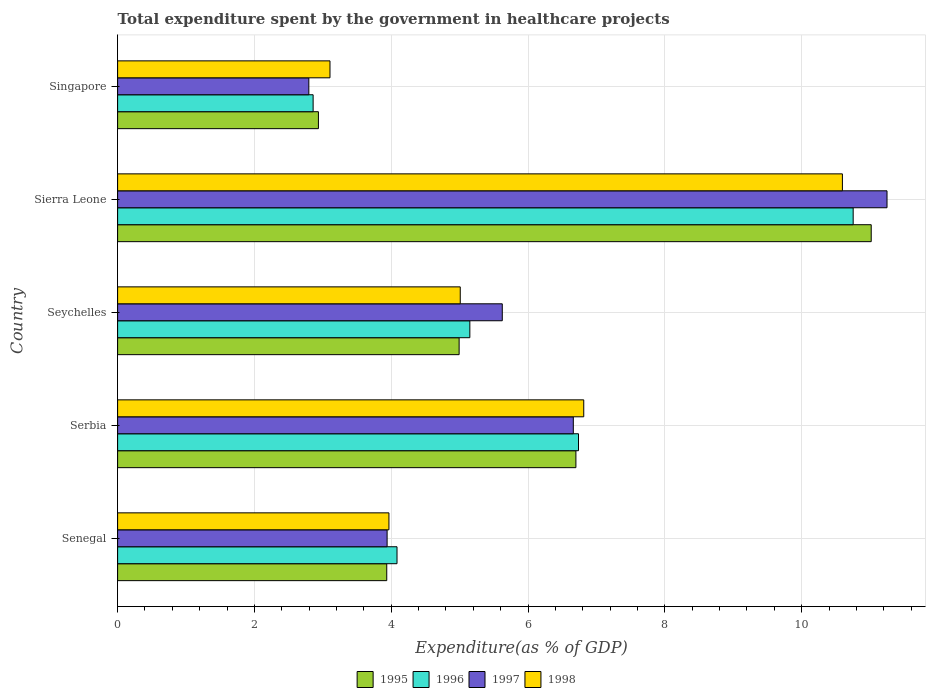How many different coloured bars are there?
Provide a short and direct response. 4. Are the number of bars per tick equal to the number of legend labels?
Your answer should be compact. Yes. How many bars are there on the 5th tick from the top?
Keep it short and to the point. 4. What is the label of the 5th group of bars from the top?
Your answer should be very brief. Senegal. In how many cases, is the number of bars for a given country not equal to the number of legend labels?
Provide a short and direct response. 0. What is the total expenditure spent by the government in healthcare projects in 1997 in Senegal?
Your response must be concise. 3.94. Across all countries, what is the maximum total expenditure spent by the government in healthcare projects in 1996?
Offer a terse response. 10.75. Across all countries, what is the minimum total expenditure spent by the government in healthcare projects in 1997?
Your answer should be very brief. 2.8. In which country was the total expenditure spent by the government in healthcare projects in 1997 maximum?
Provide a succinct answer. Sierra Leone. In which country was the total expenditure spent by the government in healthcare projects in 1997 minimum?
Provide a short and direct response. Singapore. What is the total total expenditure spent by the government in healthcare projects in 1995 in the graph?
Your response must be concise. 29.58. What is the difference between the total expenditure spent by the government in healthcare projects in 1997 in Senegal and that in Sierra Leone?
Offer a terse response. -7.31. What is the difference between the total expenditure spent by the government in healthcare projects in 1998 in Serbia and the total expenditure spent by the government in healthcare projects in 1997 in Sierra Leone?
Your answer should be compact. -4.43. What is the average total expenditure spent by the government in healthcare projects in 1995 per country?
Make the answer very short. 5.92. What is the difference between the total expenditure spent by the government in healthcare projects in 1995 and total expenditure spent by the government in healthcare projects in 1998 in Senegal?
Make the answer very short. -0.03. In how many countries, is the total expenditure spent by the government in healthcare projects in 1995 greater than 8.4 %?
Offer a very short reply. 1. What is the ratio of the total expenditure spent by the government in healthcare projects in 1995 in Senegal to that in Sierra Leone?
Offer a terse response. 0.36. Is the total expenditure spent by the government in healthcare projects in 1995 in Senegal less than that in Serbia?
Make the answer very short. Yes. Is the difference between the total expenditure spent by the government in healthcare projects in 1995 in Sierra Leone and Singapore greater than the difference between the total expenditure spent by the government in healthcare projects in 1998 in Sierra Leone and Singapore?
Give a very brief answer. Yes. What is the difference between the highest and the second highest total expenditure spent by the government in healthcare projects in 1996?
Keep it short and to the point. 4.02. What is the difference between the highest and the lowest total expenditure spent by the government in healthcare projects in 1998?
Make the answer very short. 7.49. In how many countries, is the total expenditure spent by the government in healthcare projects in 1997 greater than the average total expenditure spent by the government in healthcare projects in 1997 taken over all countries?
Provide a succinct answer. 2. Is it the case that in every country, the sum of the total expenditure spent by the government in healthcare projects in 1998 and total expenditure spent by the government in healthcare projects in 1995 is greater than the sum of total expenditure spent by the government in healthcare projects in 1996 and total expenditure spent by the government in healthcare projects in 1997?
Make the answer very short. No. What is the difference between two consecutive major ticks on the X-axis?
Provide a short and direct response. 2. Does the graph contain grids?
Ensure brevity in your answer.  Yes. Where does the legend appear in the graph?
Provide a short and direct response. Bottom center. What is the title of the graph?
Provide a succinct answer. Total expenditure spent by the government in healthcare projects. What is the label or title of the X-axis?
Your answer should be compact. Expenditure(as % of GDP). What is the Expenditure(as % of GDP) of 1995 in Senegal?
Give a very brief answer. 3.93. What is the Expenditure(as % of GDP) in 1996 in Senegal?
Keep it short and to the point. 4.08. What is the Expenditure(as % of GDP) of 1997 in Senegal?
Offer a very short reply. 3.94. What is the Expenditure(as % of GDP) in 1998 in Senegal?
Ensure brevity in your answer.  3.97. What is the Expenditure(as % of GDP) of 1995 in Serbia?
Make the answer very short. 6.7. What is the Expenditure(as % of GDP) in 1996 in Serbia?
Your answer should be compact. 6.74. What is the Expenditure(as % of GDP) of 1997 in Serbia?
Provide a succinct answer. 6.66. What is the Expenditure(as % of GDP) in 1998 in Serbia?
Your answer should be compact. 6.81. What is the Expenditure(as % of GDP) of 1995 in Seychelles?
Keep it short and to the point. 4.99. What is the Expenditure(as % of GDP) in 1996 in Seychelles?
Provide a succinct answer. 5.15. What is the Expenditure(as % of GDP) of 1997 in Seychelles?
Keep it short and to the point. 5.62. What is the Expenditure(as % of GDP) in 1998 in Seychelles?
Keep it short and to the point. 5.01. What is the Expenditure(as % of GDP) in 1995 in Sierra Leone?
Keep it short and to the point. 11.02. What is the Expenditure(as % of GDP) of 1996 in Sierra Leone?
Offer a terse response. 10.75. What is the Expenditure(as % of GDP) in 1997 in Sierra Leone?
Your answer should be very brief. 11.25. What is the Expenditure(as % of GDP) of 1998 in Sierra Leone?
Make the answer very short. 10.59. What is the Expenditure(as % of GDP) in 1995 in Singapore?
Make the answer very short. 2.94. What is the Expenditure(as % of GDP) in 1996 in Singapore?
Your answer should be compact. 2.86. What is the Expenditure(as % of GDP) in 1997 in Singapore?
Your answer should be very brief. 2.8. What is the Expenditure(as % of GDP) of 1998 in Singapore?
Ensure brevity in your answer.  3.1. Across all countries, what is the maximum Expenditure(as % of GDP) of 1995?
Provide a short and direct response. 11.02. Across all countries, what is the maximum Expenditure(as % of GDP) of 1996?
Your answer should be very brief. 10.75. Across all countries, what is the maximum Expenditure(as % of GDP) in 1997?
Ensure brevity in your answer.  11.25. Across all countries, what is the maximum Expenditure(as % of GDP) of 1998?
Your answer should be very brief. 10.59. Across all countries, what is the minimum Expenditure(as % of GDP) in 1995?
Your answer should be very brief. 2.94. Across all countries, what is the minimum Expenditure(as % of GDP) of 1996?
Offer a terse response. 2.86. Across all countries, what is the minimum Expenditure(as % of GDP) in 1997?
Ensure brevity in your answer.  2.8. Across all countries, what is the minimum Expenditure(as % of GDP) of 1998?
Your answer should be compact. 3.1. What is the total Expenditure(as % of GDP) in 1995 in the graph?
Keep it short and to the point. 29.58. What is the total Expenditure(as % of GDP) in 1996 in the graph?
Your answer should be very brief. 29.58. What is the total Expenditure(as % of GDP) in 1997 in the graph?
Your answer should be very brief. 30.27. What is the total Expenditure(as % of GDP) in 1998 in the graph?
Your answer should be very brief. 29.49. What is the difference between the Expenditure(as % of GDP) of 1995 in Senegal and that in Serbia?
Give a very brief answer. -2.76. What is the difference between the Expenditure(as % of GDP) in 1996 in Senegal and that in Serbia?
Offer a very short reply. -2.65. What is the difference between the Expenditure(as % of GDP) in 1997 in Senegal and that in Serbia?
Offer a very short reply. -2.72. What is the difference between the Expenditure(as % of GDP) in 1998 in Senegal and that in Serbia?
Make the answer very short. -2.85. What is the difference between the Expenditure(as % of GDP) in 1995 in Senegal and that in Seychelles?
Provide a short and direct response. -1.06. What is the difference between the Expenditure(as % of GDP) in 1996 in Senegal and that in Seychelles?
Your answer should be compact. -1.06. What is the difference between the Expenditure(as % of GDP) in 1997 in Senegal and that in Seychelles?
Make the answer very short. -1.68. What is the difference between the Expenditure(as % of GDP) in 1998 in Senegal and that in Seychelles?
Give a very brief answer. -1.04. What is the difference between the Expenditure(as % of GDP) in 1995 in Senegal and that in Sierra Leone?
Give a very brief answer. -7.08. What is the difference between the Expenditure(as % of GDP) of 1996 in Senegal and that in Sierra Leone?
Provide a succinct answer. -6.67. What is the difference between the Expenditure(as % of GDP) in 1997 in Senegal and that in Sierra Leone?
Your answer should be very brief. -7.31. What is the difference between the Expenditure(as % of GDP) in 1998 in Senegal and that in Sierra Leone?
Provide a short and direct response. -6.63. What is the difference between the Expenditure(as % of GDP) in 1996 in Senegal and that in Singapore?
Offer a terse response. 1.23. What is the difference between the Expenditure(as % of GDP) of 1997 in Senegal and that in Singapore?
Your response must be concise. 1.14. What is the difference between the Expenditure(as % of GDP) in 1998 in Senegal and that in Singapore?
Ensure brevity in your answer.  0.86. What is the difference between the Expenditure(as % of GDP) of 1995 in Serbia and that in Seychelles?
Offer a terse response. 1.71. What is the difference between the Expenditure(as % of GDP) in 1996 in Serbia and that in Seychelles?
Your response must be concise. 1.59. What is the difference between the Expenditure(as % of GDP) of 1997 in Serbia and that in Seychelles?
Ensure brevity in your answer.  1.04. What is the difference between the Expenditure(as % of GDP) in 1998 in Serbia and that in Seychelles?
Make the answer very short. 1.81. What is the difference between the Expenditure(as % of GDP) of 1995 in Serbia and that in Sierra Leone?
Provide a short and direct response. -4.32. What is the difference between the Expenditure(as % of GDP) of 1996 in Serbia and that in Sierra Leone?
Provide a succinct answer. -4.02. What is the difference between the Expenditure(as % of GDP) of 1997 in Serbia and that in Sierra Leone?
Your answer should be very brief. -4.59. What is the difference between the Expenditure(as % of GDP) in 1998 in Serbia and that in Sierra Leone?
Offer a terse response. -3.78. What is the difference between the Expenditure(as % of GDP) of 1995 in Serbia and that in Singapore?
Provide a short and direct response. 3.76. What is the difference between the Expenditure(as % of GDP) of 1996 in Serbia and that in Singapore?
Ensure brevity in your answer.  3.88. What is the difference between the Expenditure(as % of GDP) of 1997 in Serbia and that in Singapore?
Make the answer very short. 3.87. What is the difference between the Expenditure(as % of GDP) in 1998 in Serbia and that in Singapore?
Ensure brevity in your answer.  3.71. What is the difference between the Expenditure(as % of GDP) in 1995 in Seychelles and that in Sierra Leone?
Give a very brief answer. -6.02. What is the difference between the Expenditure(as % of GDP) in 1996 in Seychelles and that in Sierra Leone?
Keep it short and to the point. -5.6. What is the difference between the Expenditure(as % of GDP) in 1997 in Seychelles and that in Sierra Leone?
Ensure brevity in your answer.  -5.62. What is the difference between the Expenditure(as % of GDP) of 1998 in Seychelles and that in Sierra Leone?
Offer a terse response. -5.59. What is the difference between the Expenditure(as % of GDP) of 1995 in Seychelles and that in Singapore?
Your answer should be compact. 2.06. What is the difference between the Expenditure(as % of GDP) in 1996 in Seychelles and that in Singapore?
Ensure brevity in your answer.  2.29. What is the difference between the Expenditure(as % of GDP) in 1997 in Seychelles and that in Singapore?
Provide a short and direct response. 2.83. What is the difference between the Expenditure(as % of GDP) of 1998 in Seychelles and that in Singapore?
Provide a succinct answer. 1.9. What is the difference between the Expenditure(as % of GDP) in 1995 in Sierra Leone and that in Singapore?
Your answer should be very brief. 8.08. What is the difference between the Expenditure(as % of GDP) in 1996 in Sierra Leone and that in Singapore?
Your answer should be very brief. 7.89. What is the difference between the Expenditure(as % of GDP) in 1997 in Sierra Leone and that in Singapore?
Provide a short and direct response. 8.45. What is the difference between the Expenditure(as % of GDP) in 1998 in Sierra Leone and that in Singapore?
Keep it short and to the point. 7.49. What is the difference between the Expenditure(as % of GDP) of 1995 in Senegal and the Expenditure(as % of GDP) of 1996 in Serbia?
Provide a succinct answer. -2.8. What is the difference between the Expenditure(as % of GDP) of 1995 in Senegal and the Expenditure(as % of GDP) of 1997 in Serbia?
Keep it short and to the point. -2.73. What is the difference between the Expenditure(as % of GDP) of 1995 in Senegal and the Expenditure(as % of GDP) of 1998 in Serbia?
Offer a very short reply. -2.88. What is the difference between the Expenditure(as % of GDP) in 1996 in Senegal and the Expenditure(as % of GDP) in 1997 in Serbia?
Keep it short and to the point. -2.58. What is the difference between the Expenditure(as % of GDP) in 1996 in Senegal and the Expenditure(as % of GDP) in 1998 in Serbia?
Provide a succinct answer. -2.73. What is the difference between the Expenditure(as % of GDP) of 1997 in Senegal and the Expenditure(as % of GDP) of 1998 in Serbia?
Keep it short and to the point. -2.87. What is the difference between the Expenditure(as % of GDP) of 1995 in Senegal and the Expenditure(as % of GDP) of 1996 in Seychelles?
Make the answer very short. -1.21. What is the difference between the Expenditure(as % of GDP) in 1995 in Senegal and the Expenditure(as % of GDP) in 1997 in Seychelles?
Give a very brief answer. -1.69. What is the difference between the Expenditure(as % of GDP) of 1995 in Senegal and the Expenditure(as % of GDP) of 1998 in Seychelles?
Keep it short and to the point. -1.07. What is the difference between the Expenditure(as % of GDP) of 1996 in Senegal and the Expenditure(as % of GDP) of 1997 in Seychelles?
Offer a terse response. -1.54. What is the difference between the Expenditure(as % of GDP) in 1996 in Senegal and the Expenditure(as % of GDP) in 1998 in Seychelles?
Provide a succinct answer. -0.92. What is the difference between the Expenditure(as % of GDP) in 1997 in Senegal and the Expenditure(as % of GDP) in 1998 in Seychelles?
Keep it short and to the point. -1.07. What is the difference between the Expenditure(as % of GDP) in 1995 in Senegal and the Expenditure(as % of GDP) in 1996 in Sierra Leone?
Ensure brevity in your answer.  -6.82. What is the difference between the Expenditure(as % of GDP) in 1995 in Senegal and the Expenditure(as % of GDP) in 1997 in Sierra Leone?
Your answer should be compact. -7.31. What is the difference between the Expenditure(as % of GDP) in 1995 in Senegal and the Expenditure(as % of GDP) in 1998 in Sierra Leone?
Keep it short and to the point. -6.66. What is the difference between the Expenditure(as % of GDP) of 1996 in Senegal and the Expenditure(as % of GDP) of 1997 in Sierra Leone?
Ensure brevity in your answer.  -7.16. What is the difference between the Expenditure(as % of GDP) of 1996 in Senegal and the Expenditure(as % of GDP) of 1998 in Sierra Leone?
Give a very brief answer. -6.51. What is the difference between the Expenditure(as % of GDP) in 1997 in Senegal and the Expenditure(as % of GDP) in 1998 in Sierra Leone?
Your answer should be compact. -6.66. What is the difference between the Expenditure(as % of GDP) of 1995 in Senegal and the Expenditure(as % of GDP) of 1996 in Singapore?
Give a very brief answer. 1.08. What is the difference between the Expenditure(as % of GDP) of 1995 in Senegal and the Expenditure(as % of GDP) of 1997 in Singapore?
Offer a very short reply. 1.14. What is the difference between the Expenditure(as % of GDP) of 1995 in Senegal and the Expenditure(as % of GDP) of 1998 in Singapore?
Offer a terse response. 0.83. What is the difference between the Expenditure(as % of GDP) of 1996 in Senegal and the Expenditure(as % of GDP) of 1997 in Singapore?
Your response must be concise. 1.29. What is the difference between the Expenditure(as % of GDP) in 1996 in Senegal and the Expenditure(as % of GDP) in 1998 in Singapore?
Your answer should be very brief. 0.98. What is the difference between the Expenditure(as % of GDP) in 1997 in Senegal and the Expenditure(as % of GDP) in 1998 in Singapore?
Provide a short and direct response. 0.83. What is the difference between the Expenditure(as % of GDP) of 1995 in Serbia and the Expenditure(as % of GDP) of 1996 in Seychelles?
Your answer should be compact. 1.55. What is the difference between the Expenditure(as % of GDP) of 1995 in Serbia and the Expenditure(as % of GDP) of 1997 in Seychelles?
Keep it short and to the point. 1.08. What is the difference between the Expenditure(as % of GDP) of 1995 in Serbia and the Expenditure(as % of GDP) of 1998 in Seychelles?
Your answer should be very brief. 1.69. What is the difference between the Expenditure(as % of GDP) of 1996 in Serbia and the Expenditure(as % of GDP) of 1997 in Seychelles?
Provide a succinct answer. 1.11. What is the difference between the Expenditure(as % of GDP) in 1996 in Serbia and the Expenditure(as % of GDP) in 1998 in Seychelles?
Your answer should be compact. 1.73. What is the difference between the Expenditure(as % of GDP) of 1997 in Serbia and the Expenditure(as % of GDP) of 1998 in Seychelles?
Make the answer very short. 1.65. What is the difference between the Expenditure(as % of GDP) of 1995 in Serbia and the Expenditure(as % of GDP) of 1996 in Sierra Leone?
Provide a succinct answer. -4.05. What is the difference between the Expenditure(as % of GDP) in 1995 in Serbia and the Expenditure(as % of GDP) in 1997 in Sierra Leone?
Offer a terse response. -4.55. What is the difference between the Expenditure(as % of GDP) of 1995 in Serbia and the Expenditure(as % of GDP) of 1998 in Sierra Leone?
Give a very brief answer. -3.9. What is the difference between the Expenditure(as % of GDP) of 1996 in Serbia and the Expenditure(as % of GDP) of 1997 in Sierra Leone?
Your response must be concise. -4.51. What is the difference between the Expenditure(as % of GDP) in 1996 in Serbia and the Expenditure(as % of GDP) in 1998 in Sierra Leone?
Your answer should be very brief. -3.86. What is the difference between the Expenditure(as % of GDP) of 1997 in Serbia and the Expenditure(as % of GDP) of 1998 in Sierra Leone?
Your answer should be compact. -3.93. What is the difference between the Expenditure(as % of GDP) of 1995 in Serbia and the Expenditure(as % of GDP) of 1996 in Singapore?
Make the answer very short. 3.84. What is the difference between the Expenditure(as % of GDP) of 1995 in Serbia and the Expenditure(as % of GDP) of 1997 in Singapore?
Provide a succinct answer. 3.9. What is the difference between the Expenditure(as % of GDP) in 1995 in Serbia and the Expenditure(as % of GDP) in 1998 in Singapore?
Provide a succinct answer. 3.59. What is the difference between the Expenditure(as % of GDP) of 1996 in Serbia and the Expenditure(as % of GDP) of 1997 in Singapore?
Keep it short and to the point. 3.94. What is the difference between the Expenditure(as % of GDP) of 1996 in Serbia and the Expenditure(as % of GDP) of 1998 in Singapore?
Your answer should be compact. 3.63. What is the difference between the Expenditure(as % of GDP) in 1997 in Serbia and the Expenditure(as % of GDP) in 1998 in Singapore?
Ensure brevity in your answer.  3.56. What is the difference between the Expenditure(as % of GDP) in 1995 in Seychelles and the Expenditure(as % of GDP) in 1996 in Sierra Leone?
Keep it short and to the point. -5.76. What is the difference between the Expenditure(as % of GDP) of 1995 in Seychelles and the Expenditure(as % of GDP) of 1997 in Sierra Leone?
Provide a short and direct response. -6.25. What is the difference between the Expenditure(as % of GDP) of 1995 in Seychelles and the Expenditure(as % of GDP) of 1998 in Sierra Leone?
Ensure brevity in your answer.  -5.6. What is the difference between the Expenditure(as % of GDP) in 1996 in Seychelles and the Expenditure(as % of GDP) in 1997 in Sierra Leone?
Ensure brevity in your answer.  -6.1. What is the difference between the Expenditure(as % of GDP) of 1996 in Seychelles and the Expenditure(as % of GDP) of 1998 in Sierra Leone?
Make the answer very short. -5.45. What is the difference between the Expenditure(as % of GDP) in 1997 in Seychelles and the Expenditure(as % of GDP) in 1998 in Sierra Leone?
Your answer should be compact. -4.97. What is the difference between the Expenditure(as % of GDP) of 1995 in Seychelles and the Expenditure(as % of GDP) of 1996 in Singapore?
Your response must be concise. 2.13. What is the difference between the Expenditure(as % of GDP) of 1995 in Seychelles and the Expenditure(as % of GDP) of 1997 in Singapore?
Your answer should be very brief. 2.2. What is the difference between the Expenditure(as % of GDP) of 1995 in Seychelles and the Expenditure(as % of GDP) of 1998 in Singapore?
Offer a terse response. 1.89. What is the difference between the Expenditure(as % of GDP) of 1996 in Seychelles and the Expenditure(as % of GDP) of 1997 in Singapore?
Provide a short and direct response. 2.35. What is the difference between the Expenditure(as % of GDP) of 1996 in Seychelles and the Expenditure(as % of GDP) of 1998 in Singapore?
Offer a terse response. 2.04. What is the difference between the Expenditure(as % of GDP) of 1997 in Seychelles and the Expenditure(as % of GDP) of 1998 in Singapore?
Your answer should be very brief. 2.52. What is the difference between the Expenditure(as % of GDP) in 1995 in Sierra Leone and the Expenditure(as % of GDP) in 1996 in Singapore?
Keep it short and to the point. 8.16. What is the difference between the Expenditure(as % of GDP) of 1995 in Sierra Leone and the Expenditure(as % of GDP) of 1997 in Singapore?
Ensure brevity in your answer.  8.22. What is the difference between the Expenditure(as % of GDP) of 1995 in Sierra Leone and the Expenditure(as % of GDP) of 1998 in Singapore?
Provide a short and direct response. 7.91. What is the difference between the Expenditure(as % of GDP) in 1996 in Sierra Leone and the Expenditure(as % of GDP) in 1997 in Singapore?
Provide a short and direct response. 7.96. What is the difference between the Expenditure(as % of GDP) of 1996 in Sierra Leone and the Expenditure(as % of GDP) of 1998 in Singapore?
Offer a terse response. 7.65. What is the difference between the Expenditure(as % of GDP) of 1997 in Sierra Leone and the Expenditure(as % of GDP) of 1998 in Singapore?
Ensure brevity in your answer.  8.14. What is the average Expenditure(as % of GDP) in 1995 per country?
Offer a very short reply. 5.92. What is the average Expenditure(as % of GDP) in 1996 per country?
Provide a short and direct response. 5.92. What is the average Expenditure(as % of GDP) in 1997 per country?
Keep it short and to the point. 6.05. What is the average Expenditure(as % of GDP) in 1998 per country?
Your answer should be very brief. 5.9. What is the difference between the Expenditure(as % of GDP) in 1995 and Expenditure(as % of GDP) in 1996 in Senegal?
Your response must be concise. -0.15. What is the difference between the Expenditure(as % of GDP) of 1995 and Expenditure(as % of GDP) of 1997 in Senegal?
Your answer should be very brief. -0.01. What is the difference between the Expenditure(as % of GDP) of 1995 and Expenditure(as % of GDP) of 1998 in Senegal?
Your answer should be very brief. -0.03. What is the difference between the Expenditure(as % of GDP) in 1996 and Expenditure(as % of GDP) in 1997 in Senegal?
Your answer should be very brief. 0.14. What is the difference between the Expenditure(as % of GDP) of 1996 and Expenditure(as % of GDP) of 1998 in Senegal?
Make the answer very short. 0.12. What is the difference between the Expenditure(as % of GDP) in 1997 and Expenditure(as % of GDP) in 1998 in Senegal?
Provide a succinct answer. -0.03. What is the difference between the Expenditure(as % of GDP) of 1995 and Expenditure(as % of GDP) of 1996 in Serbia?
Ensure brevity in your answer.  -0.04. What is the difference between the Expenditure(as % of GDP) of 1995 and Expenditure(as % of GDP) of 1997 in Serbia?
Your answer should be compact. 0.04. What is the difference between the Expenditure(as % of GDP) of 1995 and Expenditure(as % of GDP) of 1998 in Serbia?
Give a very brief answer. -0.11. What is the difference between the Expenditure(as % of GDP) of 1996 and Expenditure(as % of GDP) of 1997 in Serbia?
Your response must be concise. 0.08. What is the difference between the Expenditure(as % of GDP) in 1996 and Expenditure(as % of GDP) in 1998 in Serbia?
Keep it short and to the point. -0.08. What is the difference between the Expenditure(as % of GDP) in 1997 and Expenditure(as % of GDP) in 1998 in Serbia?
Offer a very short reply. -0.15. What is the difference between the Expenditure(as % of GDP) of 1995 and Expenditure(as % of GDP) of 1996 in Seychelles?
Offer a very short reply. -0.16. What is the difference between the Expenditure(as % of GDP) in 1995 and Expenditure(as % of GDP) in 1997 in Seychelles?
Ensure brevity in your answer.  -0.63. What is the difference between the Expenditure(as % of GDP) in 1995 and Expenditure(as % of GDP) in 1998 in Seychelles?
Give a very brief answer. -0.02. What is the difference between the Expenditure(as % of GDP) of 1996 and Expenditure(as % of GDP) of 1997 in Seychelles?
Your answer should be compact. -0.47. What is the difference between the Expenditure(as % of GDP) in 1996 and Expenditure(as % of GDP) in 1998 in Seychelles?
Provide a short and direct response. 0.14. What is the difference between the Expenditure(as % of GDP) of 1997 and Expenditure(as % of GDP) of 1998 in Seychelles?
Make the answer very short. 0.61. What is the difference between the Expenditure(as % of GDP) of 1995 and Expenditure(as % of GDP) of 1996 in Sierra Leone?
Your answer should be very brief. 0.26. What is the difference between the Expenditure(as % of GDP) in 1995 and Expenditure(as % of GDP) in 1997 in Sierra Leone?
Keep it short and to the point. -0.23. What is the difference between the Expenditure(as % of GDP) in 1995 and Expenditure(as % of GDP) in 1998 in Sierra Leone?
Your answer should be very brief. 0.42. What is the difference between the Expenditure(as % of GDP) of 1996 and Expenditure(as % of GDP) of 1997 in Sierra Leone?
Ensure brevity in your answer.  -0.49. What is the difference between the Expenditure(as % of GDP) in 1996 and Expenditure(as % of GDP) in 1998 in Sierra Leone?
Keep it short and to the point. 0.16. What is the difference between the Expenditure(as % of GDP) in 1997 and Expenditure(as % of GDP) in 1998 in Sierra Leone?
Offer a very short reply. 0.65. What is the difference between the Expenditure(as % of GDP) of 1995 and Expenditure(as % of GDP) of 1996 in Singapore?
Provide a short and direct response. 0.08. What is the difference between the Expenditure(as % of GDP) of 1995 and Expenditure(as % of GDP) of 1997 in Singapore?
Your response must be concise. 0.14. What is the difference between the Expenditure(as % of GDP) of 1995 and Expenditure(as % of GDP) of 1998 in Singapore?
Your response must be concise. -0.17. What is the difference between the Expenditure(as % of GDP) in 1996 and Expenditure(as % of GDP) in 1997 in Singapore?
Make the answer very short. 0.06. What is the difference between the Expenditure(as % of GDP) of 1996 and Expenditure(as % of GDP) of 1998 in Singapore?
Make the answer very short. -0.25. What is the difference between the Expenditure(as % of GDP) in 1997 and Expenditure(as % of GDP) in 1998 in Singapore?
Provide a short and direct response. -0.31. What is the ratio of the Expenditure(as % of GDP) of 1995 in Senegal to that in Serbia?
Provide a short and direct response. 0.59. What is the ratio of the Expenditure(as % of GDP) of 1996 in Senegal to that in Serbia?
Give a very brief answer. 0.61. What is the ratio of the Expenditure(as % of GDP) in 1997 in Senegal to that in Serbia?
Your answer should be very brief. 0.59. What is the ratio of the Expenditure(as % of GDP) of 1998 in Senegal to that in Serbia?
Give a very brief answer. 0.58. What is the ratio of the Expenditure(as % of GDP) in 1995 in Senegal to that in Seychelles?
Give a very brief answer. 0.79. What is the ratio of the Expenditure(as % of GDP) in 1996 in Senegal to that in Seychelles?
Ensure brevity in your answer.  0.79. What is the ratio of the Expenditure(as % of GDP) in 1997 in Senegal to that in Seychelles?
Provide a succinct answer. 0.7. What is the ratio of the Expenditure(as % of GDP) of 1998 in Senegal to that in Seychelles?
Give a very brief answer. 0.79. What is the ratio of the Expenditure(as % of GDP) of 1995 in Senegal to that in Sierra Leone?
Ensure brevity in your answer.  0.36. What is the ratio of the Expenditure(as % of GDP) in 1996 in Senegal to that in Sierra Leone?
Provide a succinct answer. 0.38. What is the ratio of the Expenditure(as % of GDP) of 1997 in Senegal to that in Sierra Leone?
Give a very brief answer. 0.35. What is the ratio of the Expenditure(as % of GDP) of 1998 in Senegal to that in Sierra Leone?
Your answer should be very brief. 0.37. What is the ratio of the Expenditure(as % of GDP) in 1995 in Senegal to that in Singapore?
Your answer should be compact. 1.34. What is the ratio of the Expenditure(as % of GDP) of 1996 in Senegal to that in Singapore?
Keep it short and to the point. 1.43. What is the ratio of the Expenditure(as % of GDP) of 1997 in Senegal to that in Singapore?
Provide a short and direct response. 1.41. What is the ratio of the Expenditure(as % of GDP) in 1998 in Senegal to that in Singapore?
Ensure brevity in your answer.  1.28. What is the ratio of the Expenditure(as % of GDP) of 1995 in Serbia to that in Seychelles?
Your answer should be very brief. 1.34. What is the ratio of the Expenditure(as % of GDP) of 1996 in Serbia to that in Seychelles?
Ensure brevity in your answer.  1.31. What is the ratio of the Expenditure(as % of GDP) in 1997 in Serbia to that in Seychelles?
Ensure brevity in your answer.  1.18. What is the ratio of the Expenditure(as % of GDP) of 1998 in Serbia to that in Seychelles?
Your response must be concise. 1.36. What is the ratio of the Expenditure(as % of GDP) in 1995 in Serbia to that in Sierra Leone?
Your response must be concise. 0.61. What is the ratio of the Expenditure(as % of GDP) of 1996 in Serbia to that in Sierra Leone?
Give a very brief answer. 0.63. What is the ratio of the Expenditure(as % of GDP) of 1997 in Serbia to that in Sierra Leone?
Your answer should be very brief. 0.59. What is the ratio of the Expenditure(as % of GDP) in 1998 in Serbia to that in Sierra Leone?
Keep it short and to the point. 0.64. What is the ratio of the Expenditure(as % of GDP) in 1995 in Serbia to that in Singapore?
Your answer should be compact. 2.28. What is the ratio of the Expenditure(as % of GDP) of 1996 in Serbia to that in Singapore?
Give a very brief answer. 2.36. What is the ratio of the Expenditure(as % of GDP) in 1997 in Serbia to that in Singapore?
Offer a terse response. 2.38. What is the ratio of the Expenditure(as % of GDP) of 1998 in Serbia to that in Singapore?
Make the answer very short. 2.19. What is the ratio of the Expenditure(as % of GDP) in 1995 in Seychelles to that in Sierra Leone?
Provide a succinct answer. 0.45. What is the ratio of the Expenditure(as % of GDP) in 1996 in Seychelles to that in Sierra Leone?
Your answer should be very brief. 0.48. What is the ratio of the Expenditure(as % of GDP) of 1998 in Seychelles to that in Sierra Leone?
Your response must be concise. 0.47. What is the ratio of the Expenditure(as % of GDP) of 1995 in Seychelles to that in Singapore?
Give a very brief answer. 1.7. What is the ratio of the Expenditure(as % of GDP) in 1996 in Seychelles to that in Singapore?
Your answer should be compact. 1.8. What is the ratio of the Expenditure(as % of GDP) in 1997 in Seychelles to that in Singapore?
Provide a short and direct response. 2.01. What is the ratio of the Expenditure(as % of GDP) of 1998 in Seychelles to that in Singapore?
Provide a short and direct response. 1.61. What is the ratio of the Expenditure(as % of GDP) in 1995 in Sierra Leone to that in Singapore?
Provide a succinct answer. 3.75. What is the ratio of the Expenditure(as % of GDP) of 1996 in Sierra Leone to that in Singapore?
Offer a very short reply. 3.76. What is the ratio of the Expenditure(as % of GDP) of 1997 in Sierra Leone to that in Singapore?
Offer a very short reply. 4.02. What is the ratio of the Expenditure(as % of GDP) in 1998 in Sierra Leone to that in Singapore?
Ensure brevity in your answer.  3.41. What is the difference between the highest and the second highest Expenditure(as % of GDP) in 1995?
Offer a terse response. 4.32. What is the difference between the highest and the second highest Expenditure(as % of GDP) of 1996?
Provide a short and direct response. 4.02. What is the difference between the highest and the second highest Expenditure(as % of GDP) in 1997?
Provide a short and direct response. 4.59. What is the difference between the highest and the second highest Expenditure(as % of GDP) in 1998?
Your response must be concise. 3.78. What is the difference between the highest and the lowest Expenditure(as % of GDP) of 1995?
Keep it short and to the point. 8.08. What is the difference between the highest and the lowest Expenditure(as % of GDP) in 1996?
Ensure brevity in your answer.  7.89. What is the difference between the highest and the lowest Expenditure(as % of GDP) of 1997?
Make the answer very short. 8.45. What is the difference between the highest and the lowest Expenditure(as % of GDP) of 1998?
Keep it short and to the point. 7.49. 